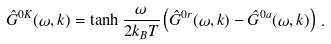Convert formula to latex. <formula><loc_0><loc_0><loc_500><loc_500>\hat { G } ^ { 0 K } ( \omega , k ) = \tanh \frac { \omega } { 2 k _ { B } T } \left ( \hat { G } ^ { 0 r } ( \omega , k ) - \hat { G } ^ { 0 a } ( \omega , k ) \right ) \, .</formula> 